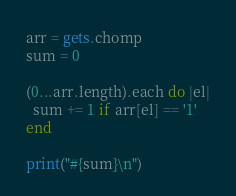<code> <loc_0><loc_0><loc_500><loc_500><_Ruby_>arr = gets.chomp
sum = 0

(0...arr.length).each do |el|
  sum += 1 if arr[el] == '1'
end

print("#{sum}\n")</code> 